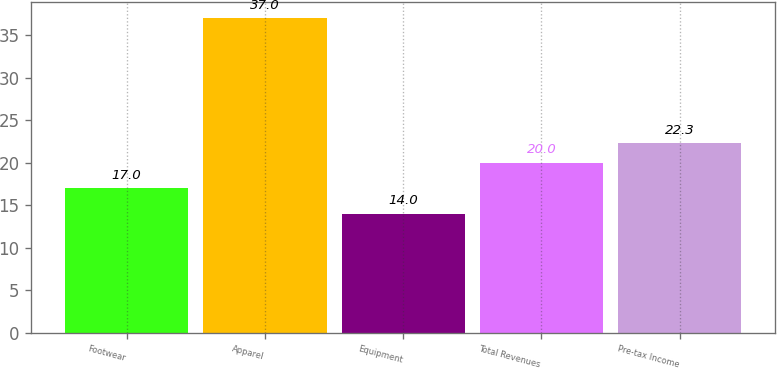Convert chart to OTSL. <chart><loc_0><loc_0><loc_500><loc_500><bar_chart><fcel>Footwear<fcel>Apparel<fcel>Equipment<fcel>Total Revenues<fcel>Pre-tax Income<nl><fcel>17<fcel>37<fcel>14<fcel>20<fcel>22.3<nl></chart> 